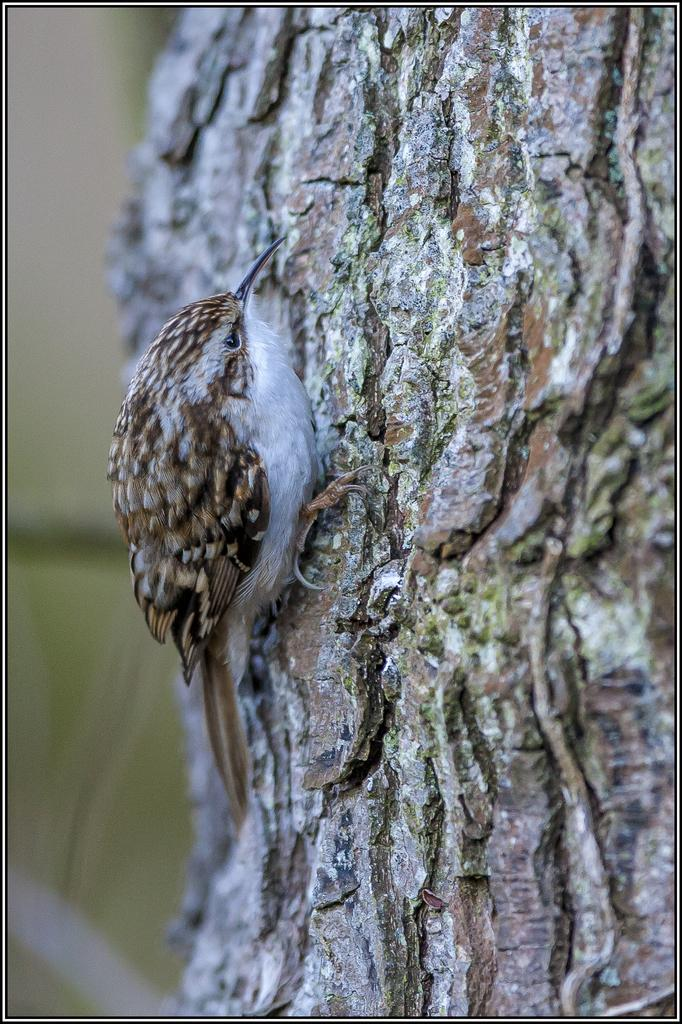What type of animal is in the image? There is a bird in the image. Where is the bird located? The bird is on a tree. Can you describe the background of the image? The background of the image is blurry. What color is the clover that the bird is holding in the image? There is no clover present in the image, and the bird is not holding anything. 